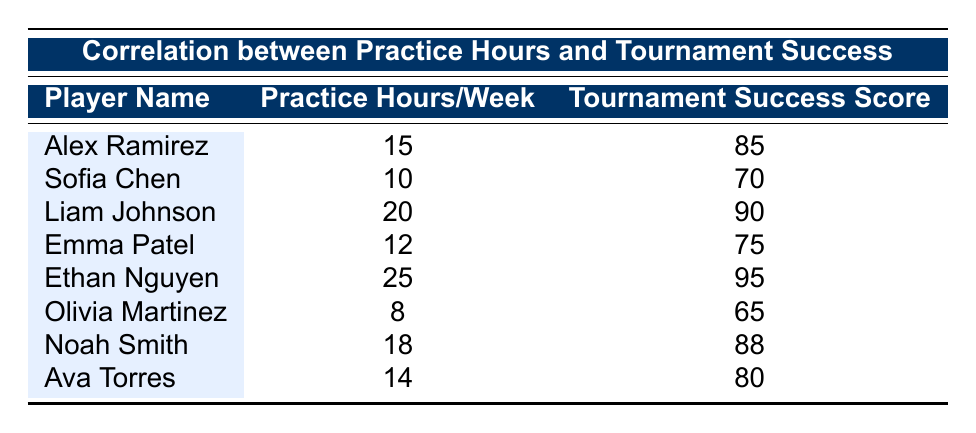What is the tournament success score of Ethan Nguyen? The table lists Ethan Nguyen's tournament success score in the corresponding row under the "Tournament Success Score" column. It shows a score of 95.
Answer: 95 Who has the highest practice hours per week? By checking each row in the "Practice Hours/Week" column, we see that Ethan Nguyen has the highest at 25 hours.
Answer: Ethan Nguyen Is Olivia Martinez's practice hours greater than 12? Comparing Olivia Martinez's practice hours (8) to 12, it is clear that 8 is less than 12, so the statement is false.
Answer: No Calculate the average practice hours per week for all players. By summing the practice hours (15 + 10 + 20 + 12 + 25 + 8 + 18 + 14) = 132, and dividing by the number of players (8), we get 132/8 = 16.5.
Answer: 16.5 Do any players have a practice hour count between 10 and 15? The table lists Sofia Chen (10), Alex Ramirez (15), and Emma Patel (12) which fits this range (not including 10 and 15), confirming that players are indeed within that range.
Answer: Yes What is the difference in tournament success scores between the highest and lowest players? Liam Johnson has the highest success score of 90 and Olivia Martinez has the lowest at 65. Calculating the difference: 90 - 65 = 25.
Answer: 25 Which player has a practice hours per week closest to the average? The average practice hours is 16.5. Checking each player's hours, we see that Noah Smith (18) is closest, only 1.5 hours higher.
Answer: Noah Smith Is there a player with a tournament success score over 85? Scanning the "Tournament Success Score" column, we find Ethan Nguyen (95) and Liam Johnson (90) both above 85, confirming that some players have scores over this threshold.
Answer: Yes 